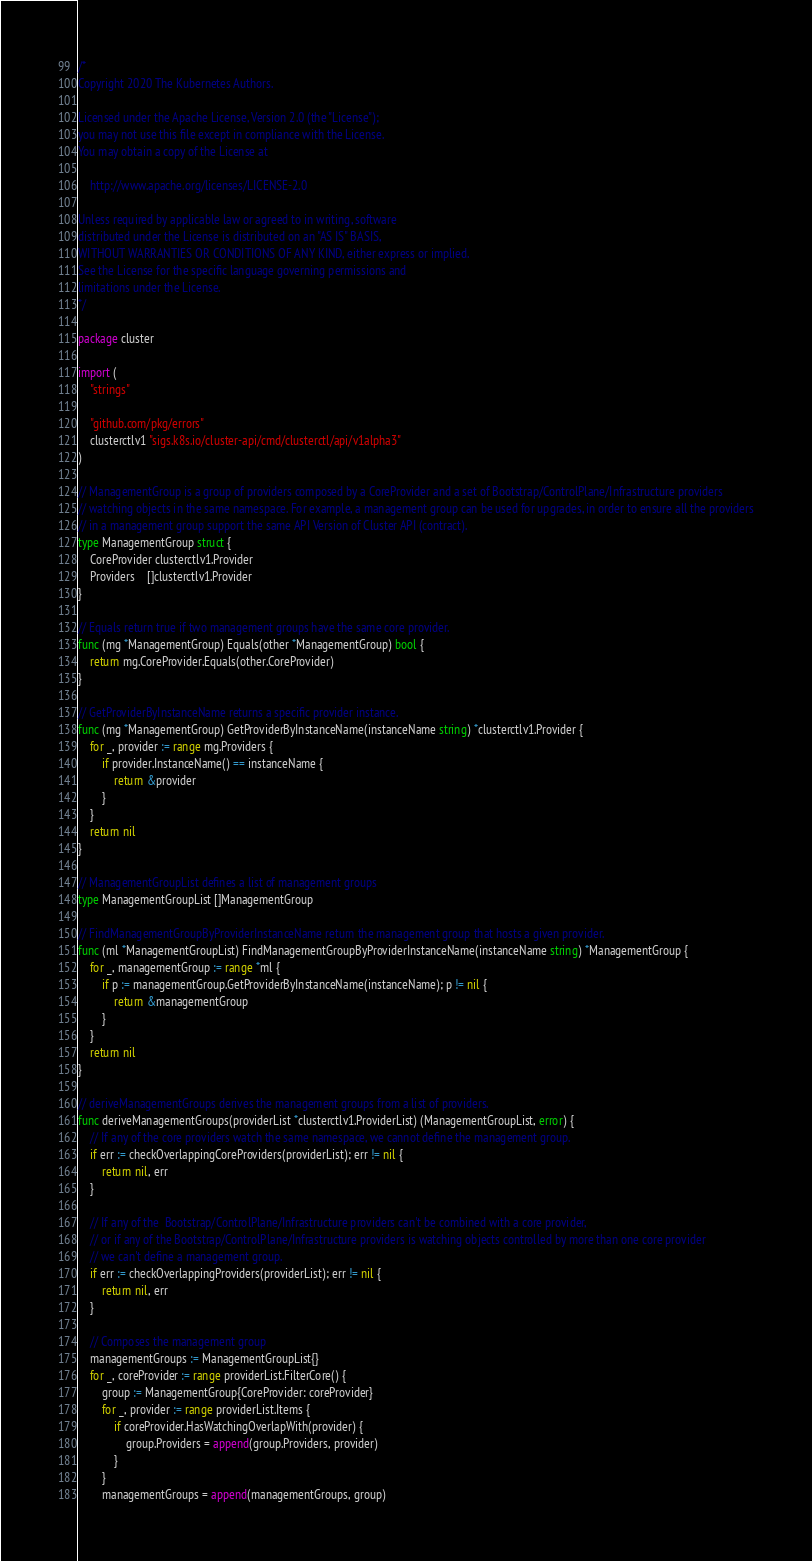<code> <loc_0><loc_0><loc_500><loc_500><_Go_>/*
Copyright 2020 The Kubernetes Authors.

Licensed under the Apache License, Version 2.0 (the "License");
you may not use this file except in compliance with the License.
You may obtain a copy of the License at

    http://www.apache.org/licenses/LICENSE-2.0

Unless required by applicable law or agreed to in writing, software
distributed under the License is distributed on an "AS IS" BASIS,
WITHOUT WARRANTIES OR CONDITIONS OF ANY KIND, either express or implied.
See the License for the specific language governing permissions and
limitations under the License.
*/

package cluster

import (
	"strings"

	"github.com/pkg/errors"
	clusterctlv1 "sigs.k8s.io/cluster-api/cmd/clusterctl/api/v1alpha3"
)

// ManagementGroup is a group of providers composed by a CoreProvider and a set of Bootstrap/ControlPlane/Infrastructure providers
// watching objects in the same namespace. For example, a management group can be used for upgrades, in order to ensure all the providers
// in a management group support the same API Version of Cluster API (contract).
type ManagementGroup struct {
	CoreProvider clusterctlv1.Provider
	Providers    []clusterctlv1.Provider
}

// Equals return true if two management groups have the same core provider.
func (mg *ManagementGroup) Equals(other *ManagementGroup) bool {
	return mg.CoreProvider.Equals(other.CoreProvider)
}

// GetProviderByInstanceName returns a specific provider instance.
func (mg *ManagementGroup) GetProviderByInstanceName(instanceName string) *clusterctlv1.Provider {
	for _, provider := range mg.Providers {
		if provider.InstanceName() == instanceName {
			return &provider
		}
	}
	return nil
}

// ManagementGroupList defines a list of management groups
type ManagementGroupList []ManagementGroup

// FindManagementGroupByProviderInstanceName return the management group that hosts a given provider.
func (ml *ManagementGroupList) FindManagementGroupByProviderInstanceName(instanceName string) *ManagementGroup {
	for _, managementGroup := range *ml {
		if p := managementGroup.GetProviderByInstanceName(instanceName); p != nil {
			return &managementGroup
		}
	}
	return nil
}

// deriveManagementGroups derives the management groups from a list of providers.
func deriveManagementGroups(providerList *clusterctlv1.ProviderList) (ManagementGroupList, error) {
	// If any of the core providers watch the same namespace, we cannot define the management group.
	if err := checkOverlappingCoreProviders(providerList); err != nil {
		return nil, err
	}

	// If any of the  Bootstrap/ControlPlane/Infrastructure providers can't be combined with a core provider,
	// or if any of the Bootstrap/ControlPlane/Infrastructure providers is watching objects controlled by more than one core provider
	// we can't define a management group.
	if err := checkOverlappingProviders(providerList); err != nil {
		return nil, err
	}

	// Composes the management group
	managementGroups := ManagementGroupList{}
	for _, coreProvider := range providerList.FilterCore() {
		group := ManagementGroup{CoreProvider: coreProvider}
		for _, provider := range providerList.Items {
			if coreProvider.HasWatchingOverlapWith(provider) {
				group.Providers = append(group.Providers, provider)
			}
		}
		managementGroups = append(managementGroups, group)</code> 